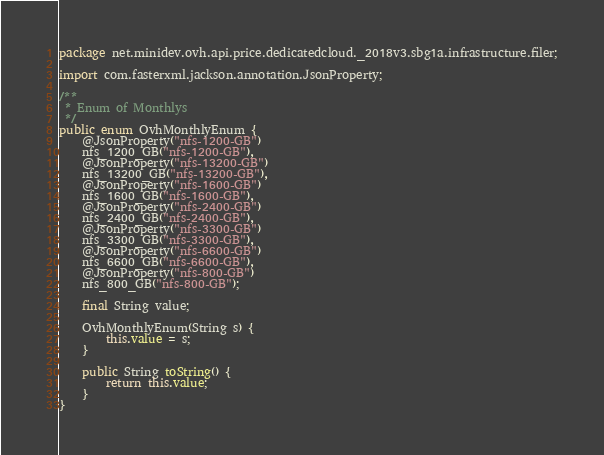Convert code to text. <code><loc_0><loc_0><loc_500><loc_500><_Java_>package net.minidev.ovh.api.price.dedicatedcloud._2018v3.sbg1a.infrastructure.filer;

import com.fasterxml.jackson.annotation.JsonProperty;

/**
 * Enum of Monthlys
 */
public enum OvhMonthlyEnum {
	@JsonProperty("nfs-1200-GB")
	nfs_1200_GB("nfs-1200-GB"),
	@JsonProperty("nfs-13200-GB")
	nfs_13200_GB("nfs-13200-GB"),
	@JsonProperty("nfs-1600-GB")
	nfs_1600_GB("nfs-1600-GB"),
	@JsonProperty("nfs-2400-GB")
	nfs_2400_GB("nfs-2400-GB"),
	@JsonProperty("nfs-3300-GB")
	nfs_3300_GB("nfs-3300-GB"),
	@JsonProperty("nfs-6600-GB")
	nfs_6600_GB("nfs-6600-GB"),
	@JsonProperty("nfs-800-GB")
	nfs_800_GB("nfs-800-GB");

	final String value;

	OvhMonthlyEnum(String s) {
		this.value = s;
	}

	public String toString() {
		return this.value;
	}
}
</code> 